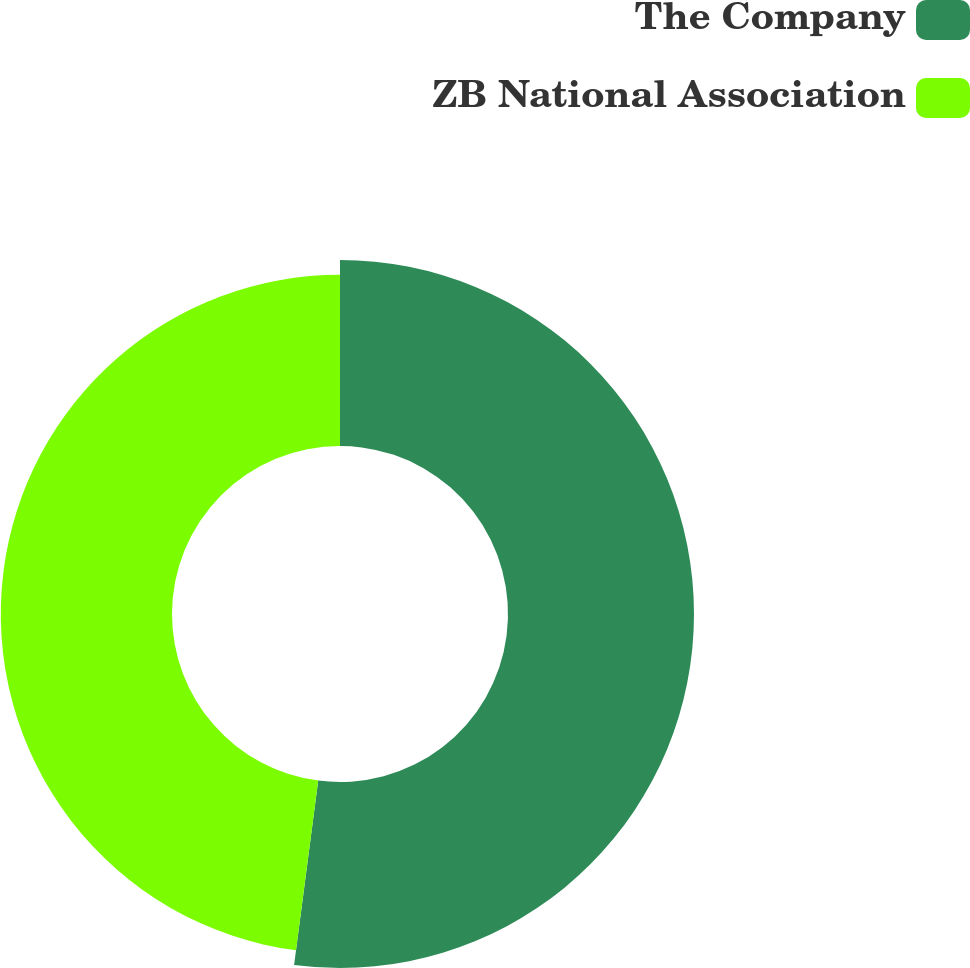Convert chart. <chart><loc_0><loc_0><loc_500><loc_500><pie_chart><fcel>The Company<fcel>ZB National Association<nl><fcel>52.07%<fcel>47.93%<nl></chart> 